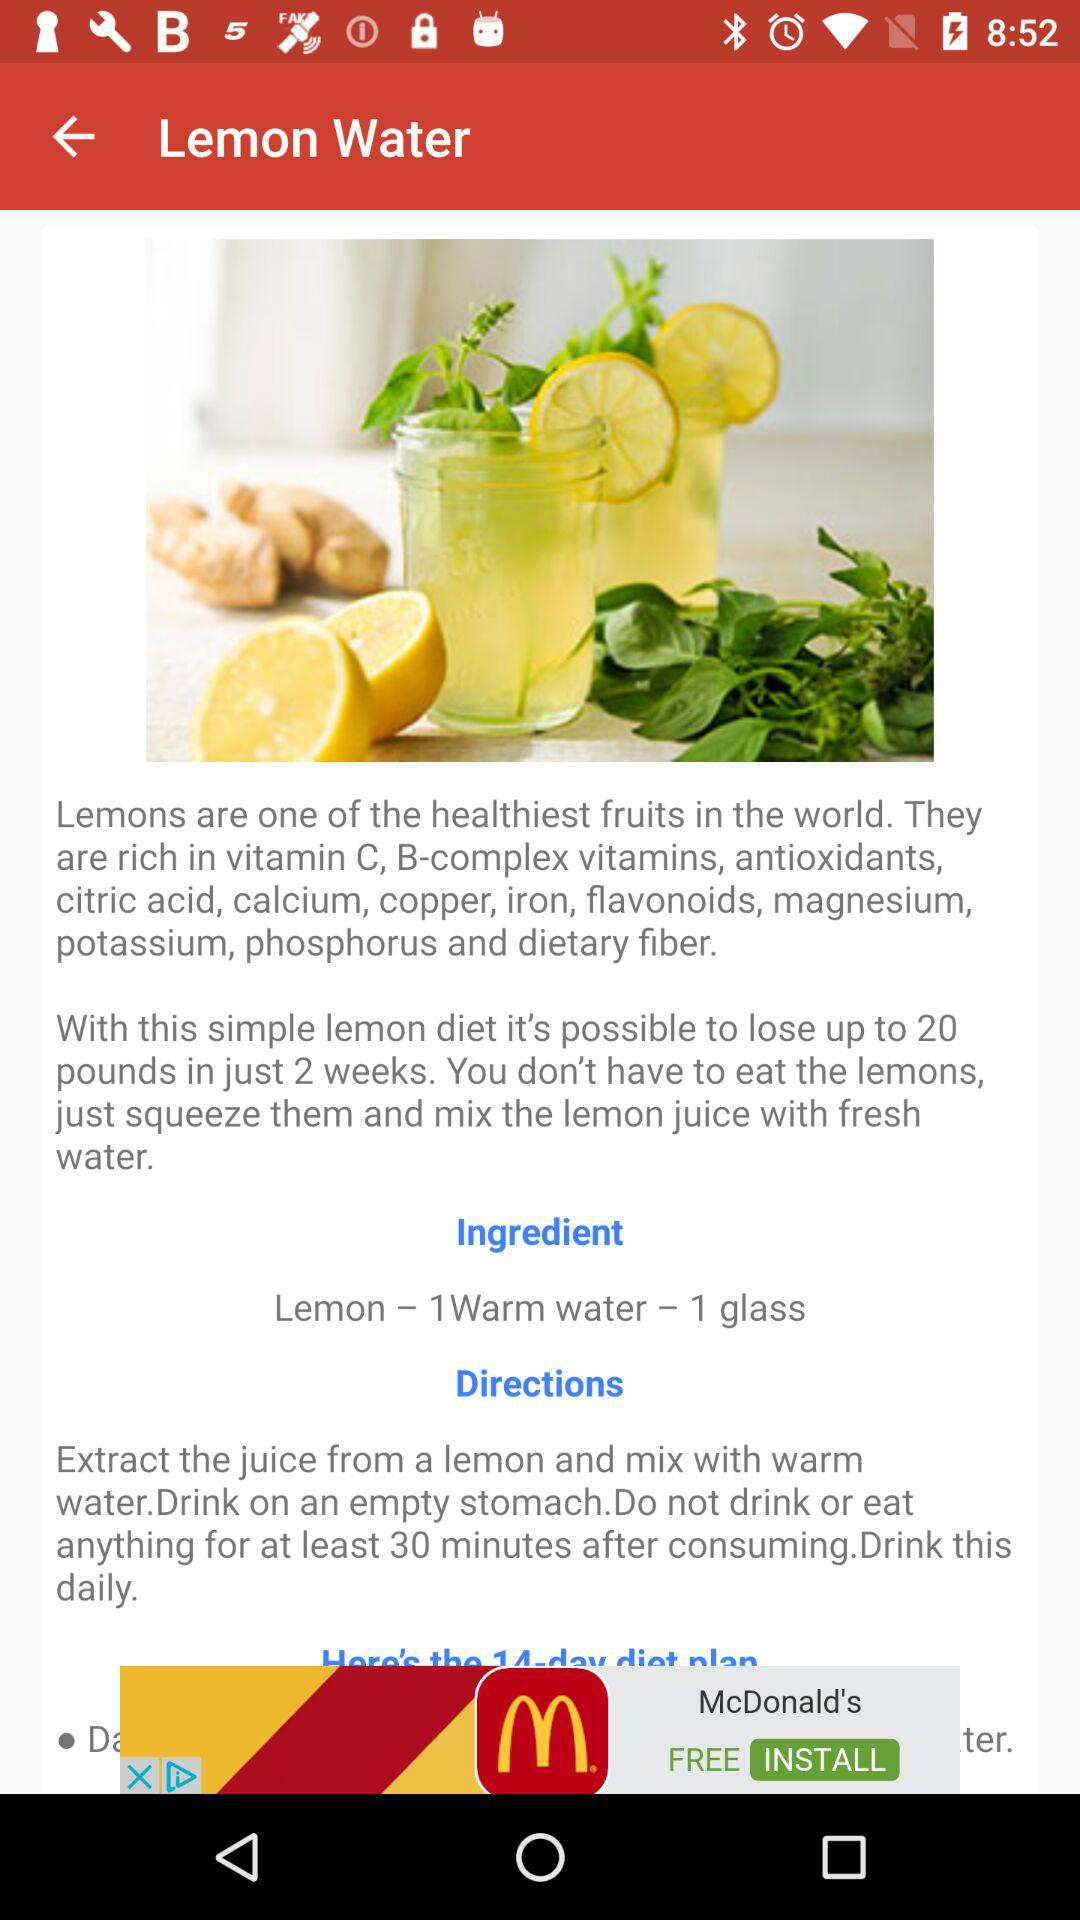What is the name of the drink? The name of the drink is "Lemon Water". 